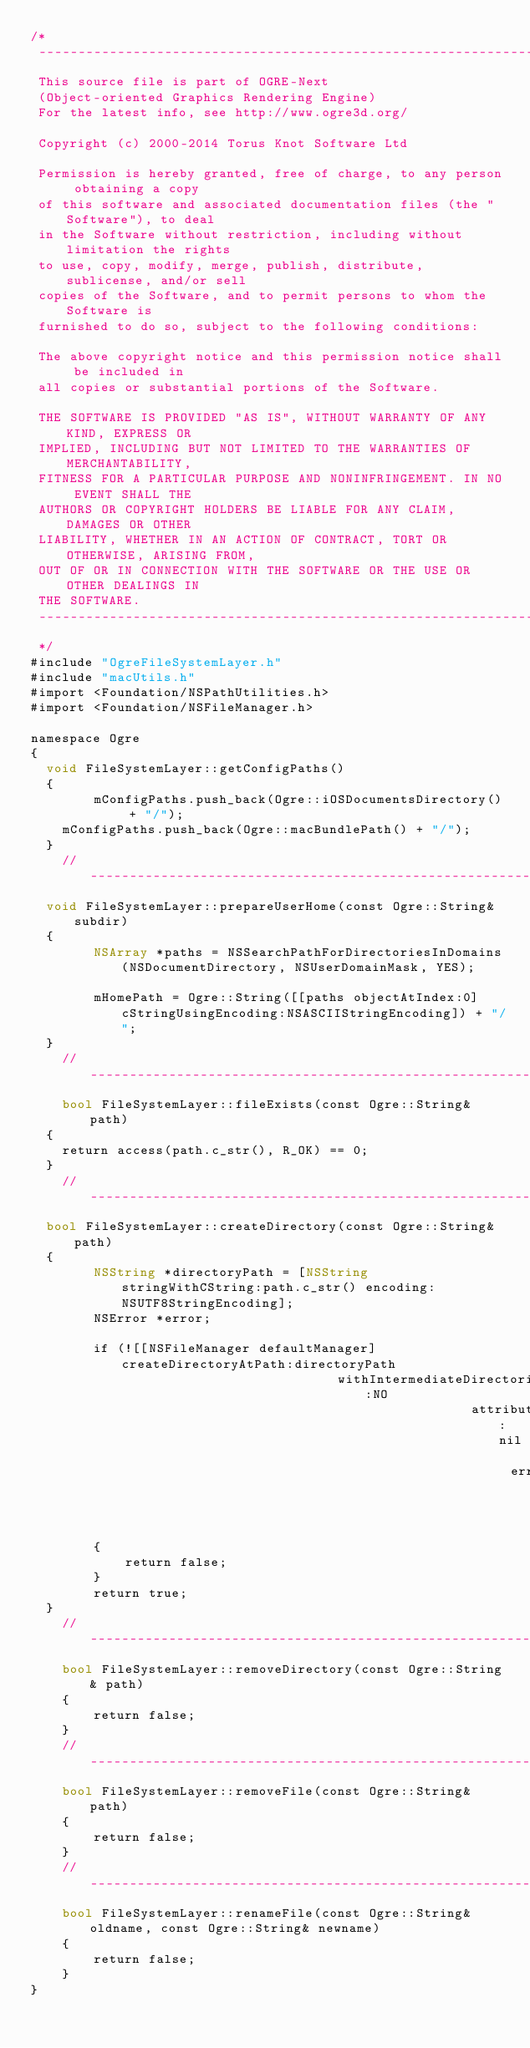<code> <loc_0><loc_0><loc_500><loc_500><_ObjectiveC_>/*
 -----------------------------------------------------------------------------
 This source file is part of OGRE-Next
 (Object-oriented Graphics Rendering Engine)
 For the latest info, see http://www.ogre3d.org/
 
 Copyright (c) 2000-2014 Torus Knot Software Ltd
 
 Permission is hereby granted, free of charge, to any person obtaining a copy
 of this software and associated documentation files (the "Software"), to deal
 in the Software without restriction, including without limitation the rights
 to use, copy, modify, merge, publish, distribute, sublicense, and/or sell
 copies of the Software, and to permit persons to whom the Software is
 furnished to do so, subject to the following conditions:
 
 The above copyright notice and this permission notice shall be included in
 all copies or substantial portions of the Software.
 
 THE SOFTWARE IS PROVIDED "AS IS", WITHOUT WARRANTY OF ANY KIND, EXPRESS OR
 IMPLIED, INCLUDING BUT NOT LIMITED TO THE WARRANTIES OF MERCHANTABILITY,
 FITNESS FOR A PARTICULAR PURPOSE AND NONINFRINGEMENT. IN NO EVENT SHALL THE
 AUTHORS OR COPYRIGHT HOLDERS BE LIABLE FOR ANY CLAIM, DAMAGES OR OTHER
 LIABILITY, WHETHER IN AN ACTION OF CONTRACT, TORT OR OTHERWISE, ARISING FROM,
 OUT OF OR IN CONNECTION WITH THE SOFTWARE OR THE USE OR OTHER DEALINGS IN
 THE SOFTWARE.
 -----------------------------------------------------------------------------
 */
#include "OgreFileSystemLayer.h"
#include "macUtils.h"
#import <Foundation/NSPathUtilities.h>
#import <Foundation/NSFileManager.h>

namespace Ogre
{
	void FileSystemLayer::getConfigPaths()
	{
        mConfigPaths.push_back(Ogre::iOSDocumentsDirectory() + "/");
		mConfigPaths.push_back(Ogre::macBundlePath() + "/");
	}
    //---------------------------------------------------------------------
	void FileSystemLayer::prepareUserHome(const Ogre::String& subdir)
	{
        NSArray *paths = NSSearchPathForDirectoriesInDomains(NSDocumentDirectory, NSUserDomainMask, YES);

        mHomePath = Ogre::String([[paths objectAtIndex:0] cStringUsingEncoding:NSASCIIStringEncoding]) + "/";
	}
    //---------------------------------------------------------------------
    bool FileSystemLayer::fileExists(const Ogre::String& path)
	{
		return access(path.c_str(), R_OK) == 0;
	}
    //---------------------------------------------------------------------
	bool FileSystemLayer::createDirectory(const Ogre::String& path)
	{
        NSString *directoryPath = [NSString stringWithCString:path.c_str() encoding:NSUTF8StringEncoding];
        NSError *error;

        if (![[NSFileManager defaultManager] createDirectoryAtPath:directoryPath
                                       withIntermediateDirectories:NO
                                                        attributes:nil
                                                             error:&error])
        {
            return false;
        }
        return true;
	}
    //---------------------------------------------------------------------
    bool FileSystemLayer::removeDirectory(const Ogre::String& path)
    {
        return false;
    }
    //---------------------------------------------------------------------
    bool FileSystemLayer::removeFile(const Ogre::String& path)
    {
        return false;
    }
    //---------------------------------------------------------------------
    bool FileSystemLayer::renameFile(const Ogre::String& oldname, const Ogre::String& newname)
    {
        return false;
    }
}
</code> 